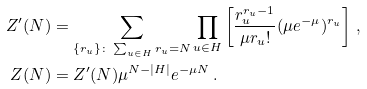<formula> <loc_0><loc_0><loc_500><loc_500>Z ^ { \prime } ( N ) & = \sum _ { \{ r _ { u } \} \colon \sum _ { u \in H } r _ { u } = N } \prod _ { u \in H } \left [ \frac { r _ { u } ^ { r _ { u } - 1 } } { \mu r _ { u } ! } ( \mu e ^ { - \mu } ) ^ { r _ { u } } \right ] \, , \\ Z ( N ) & = Z ^ { \prime } ( N ) \mu ^ { N - | H | } e ^ { - \mu N } \, .</formula> 